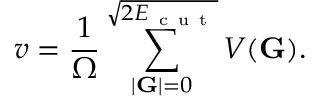Convert formula to latex. <formula><loc_0><loc_0><loc_500><loc_500>v = \frac { 1 } { \Omega } \sum _ { | G | = 0 } ^ { \sqrt { 2 E _ { c u t } } } V ( G ) .</formula> 